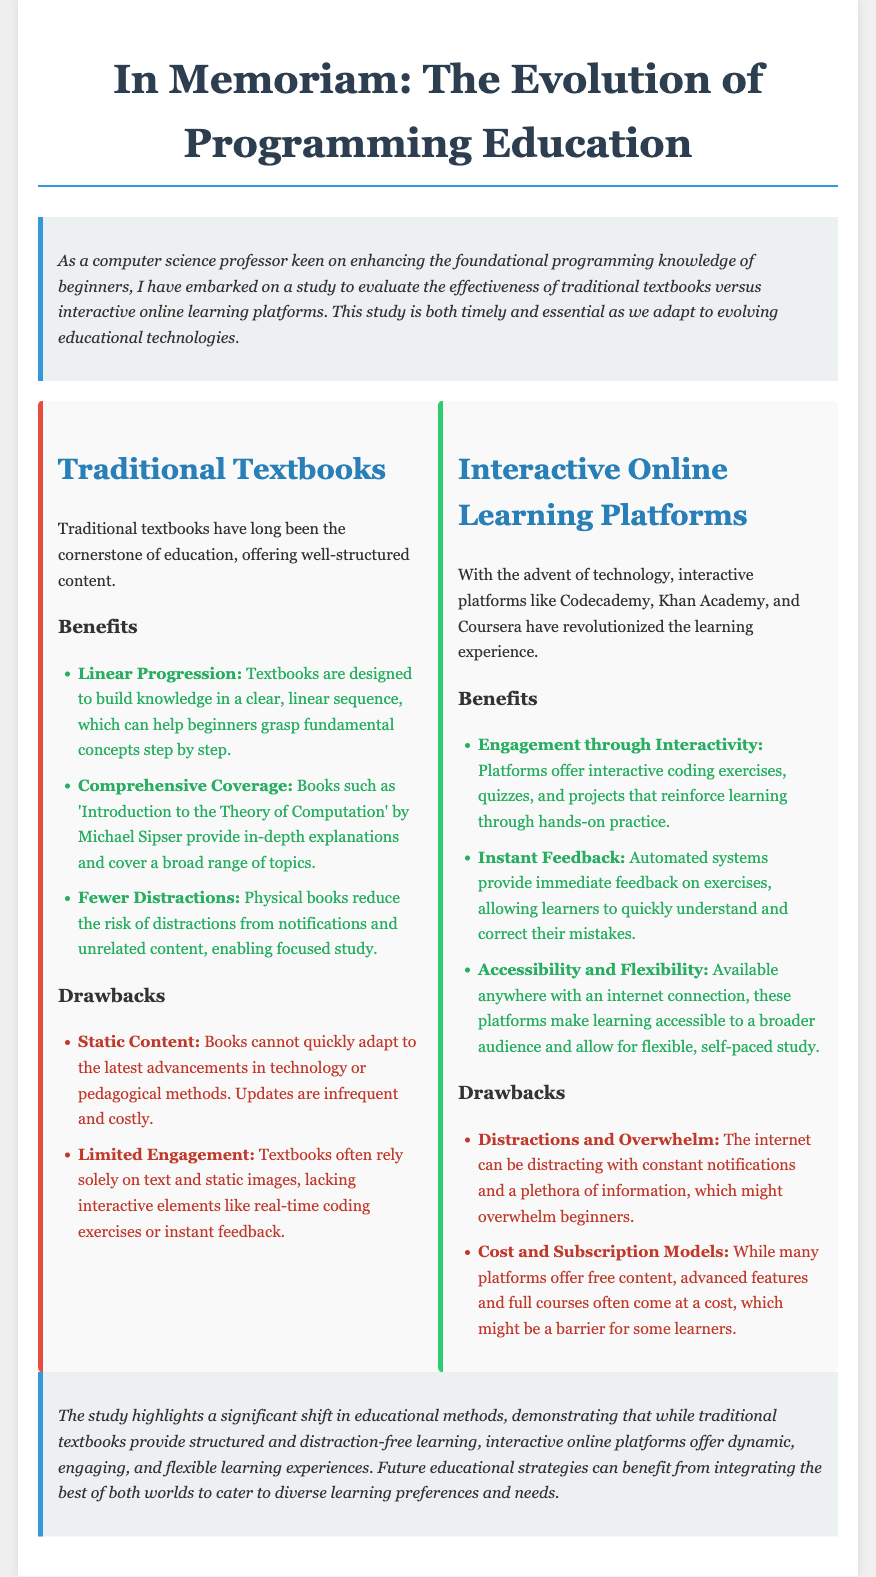What is the title of the document? The title is prominently displayed at the top of the document and identifies the subject matter.
Answer: In Memoriam: The Evolution of Programming Education Who is the intended audience of the study? The audience is indicated as being related to the improvement of programming education for beginners.
Answer: Beginners What is one benefit of traditional textbooks mentioned? The document lists several benefits, with specific examples highlighted under the benefits section.
Answer: Linear Progression What is a drawback of interactive online learning platforms? The document outlines various drawbacks in their respective sections, pointing to specific challenges faced by learners.
Answer: Distractions and Overwhelm What does the conclusion suggest about future educational strategies? The conclusion summarizes recommendations based on the comparison made and insights gathered in the study.
Answer: Integrating the best of both worlds Which platform is mentioned as an example of an interactive online learning platform? The document provides examples of interactive platforms that revolutionize learning in programming.
Answer: Codecademy How does the study characterize traditional textbooks in terms of content? The characterization is given in the context of structured educational methods and their historical significance.
Answer: Well-structured content What is one advantage of using interactive online learning platforms? One of the advantages is listed under the benefits section and emphasizes a specific aspect of learning experience.
Answer: Instant Feedback 